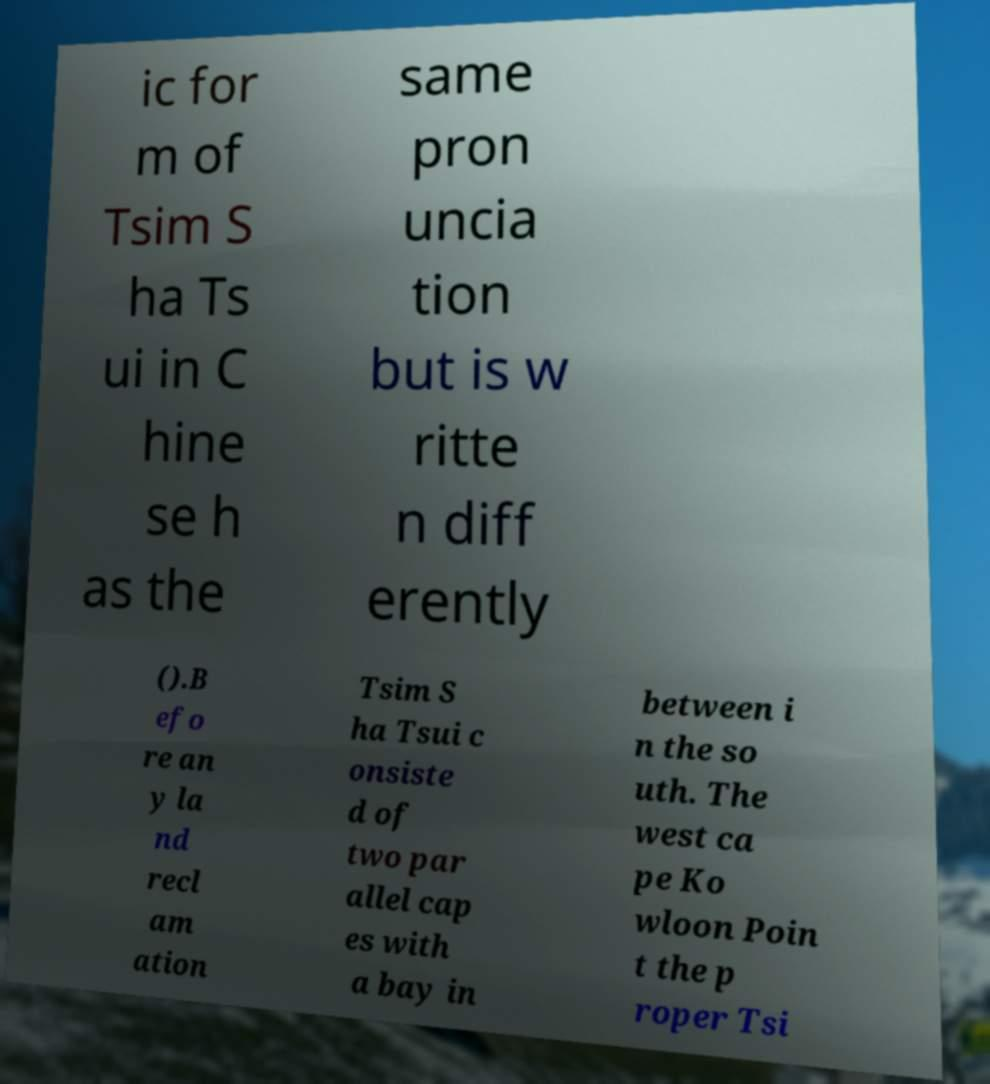There's text embedded in this image that I need extracted. Can you transcribe it verbatim? ic for m of Tsim S ha Ts ui in C hine se h as the same pron uncia tion but is w ritte n diff erently ().B efo re an y la nd recl am ation Tsim S ha Tsui c onsiste d of two par allel cap es with a bay in between i n the so uth. The west ca pe Ko wloon Poin t the p roper Tsi 